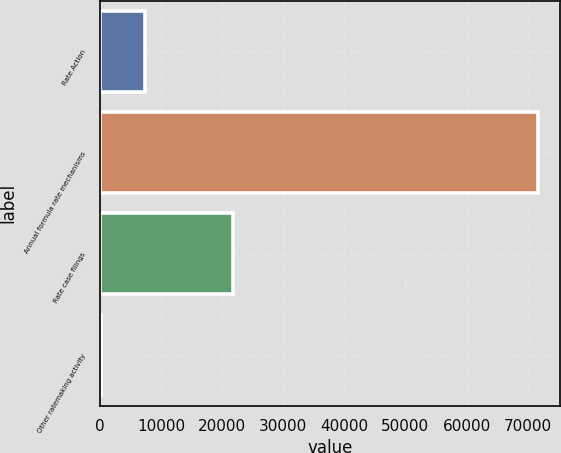Convert chart to OTSL. <chart><loc_0><loc_0><loc_500><loc_500><bar_chart><fcel>Rate Action<fcel>Annual formula rate mechanisms<fcel>Rate case filings<fcel>Other ratemaking activity<nl><fcel>7378.3<fcel>71749<fcel>21819<fcel>226<nl></chart> 